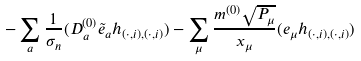Convert formula to latex. <formula><loc_0><loc_0><loc_500><loc_500>- \sum _ { a } \frac { 1 } { \sigma _ { n } } ( D _ { a } ^ { ( 0 ) } \tilde { e } _ { a } h _ { ( \cdot , i ) , ( \cdot , i ) } ) - \sum _ { \mu } \frac { m ^ { ( 0 ) } \sqrt { P _ { \mu } } } { x _ { \mu } } ( e _ { \mu } h _ { ( \cdot , i ) , ( \cdot , i ) } )</formula> 